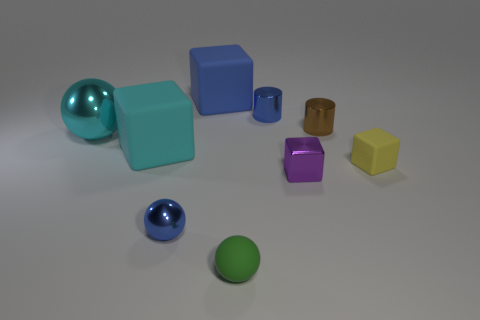Subtract all yellow blocks. Subtract all purple cylinders. How many blocks are left? 3 Subtract all spheres. How many objects are left? 6 Add 9 small cyan spheres. How many small cyan spheres exist? 9 Subtract 1 blue cubes. How many objects are left? 8 Subtract all metal balls. Subtract all blue things. How many objects are left? 4 Add 8 yellow things. How many yellow things are left? 9 